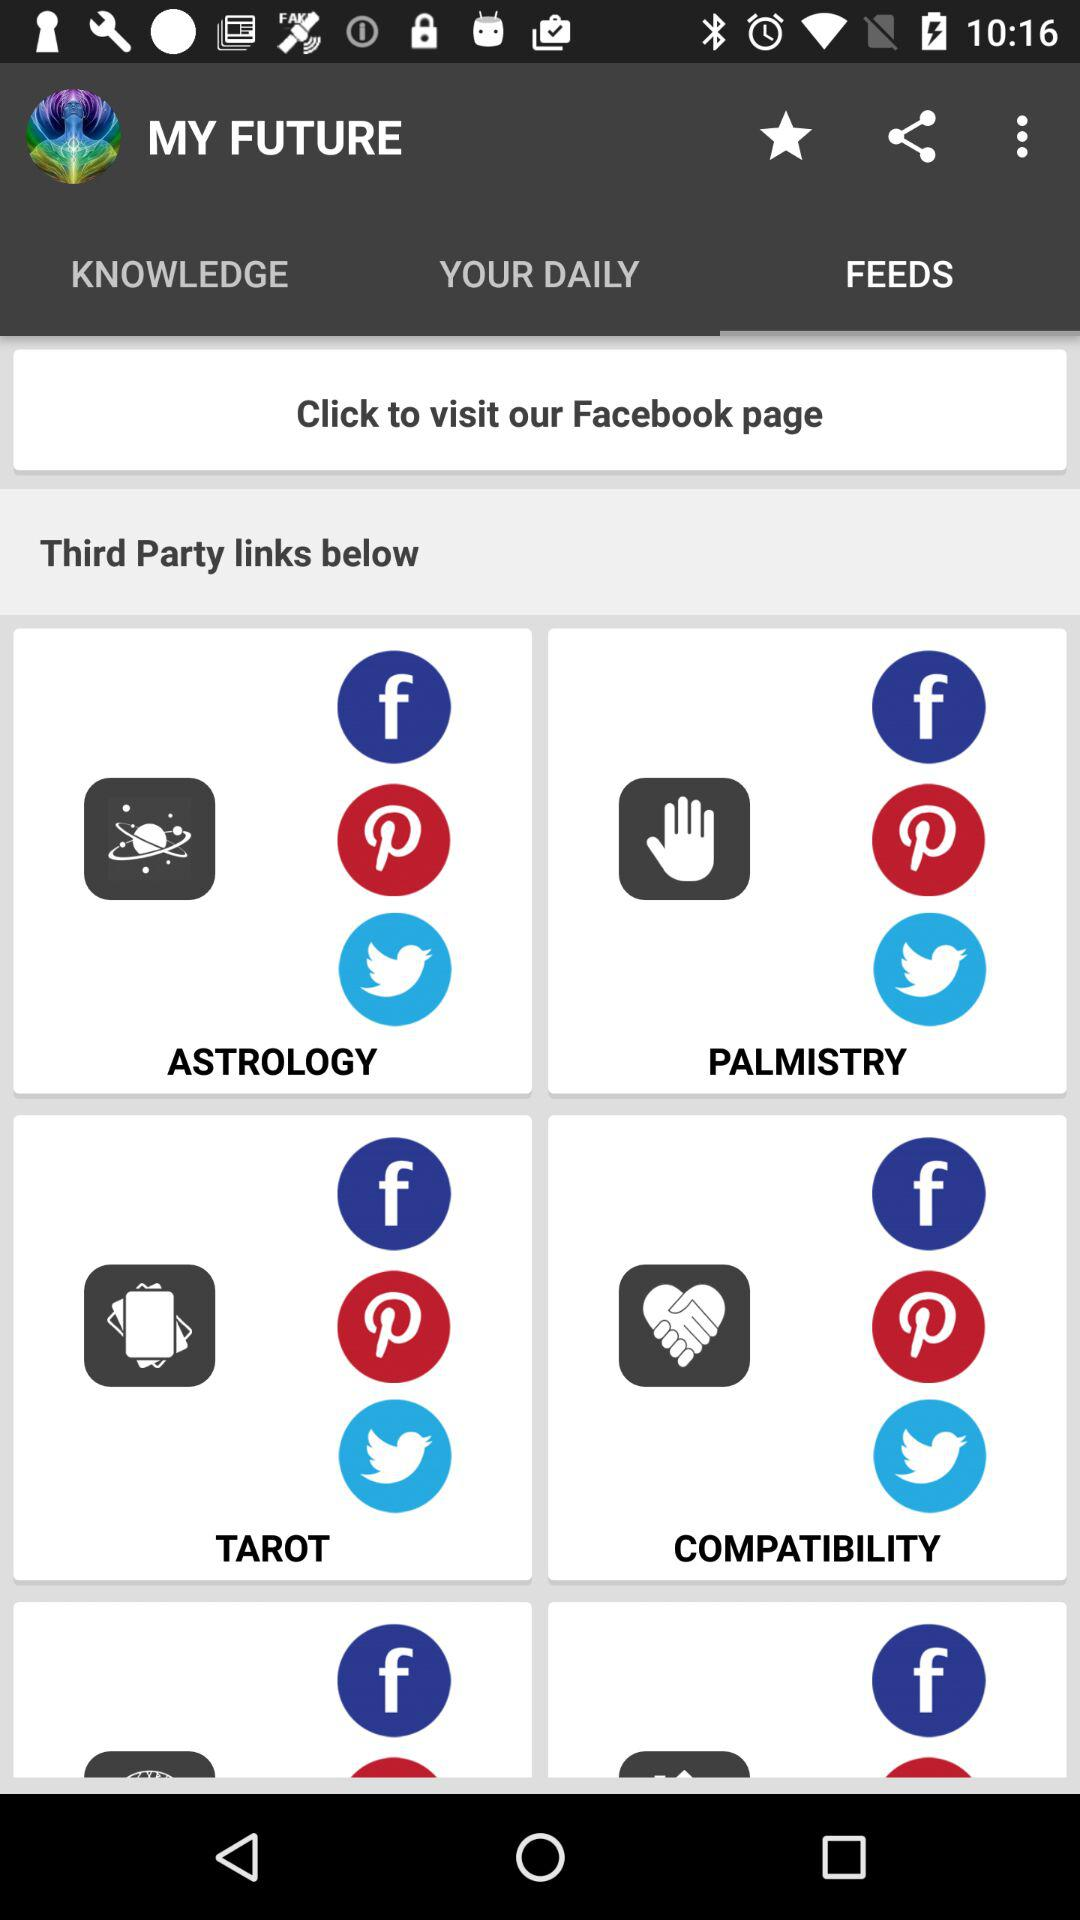What is the name of the application? The name of the application is "MY FUTURE". 